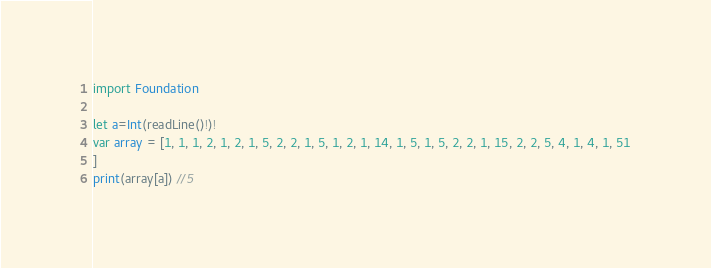<code> <loc_0><loc_0><loc_500><loc_500><_Swift_>import Foundation

let a=Int(readLine()!)!
var array = [1, 1, 1, 2, 1, 2, 1, 5, 2, 2, 1, 5, 1, 2, 1, 14, 1, 5, 1, 5, 2, 2, 1, 15, 2, 2, 5, 4, 1, 4, 1, 51
]
print(array[a]) //5
</code> 